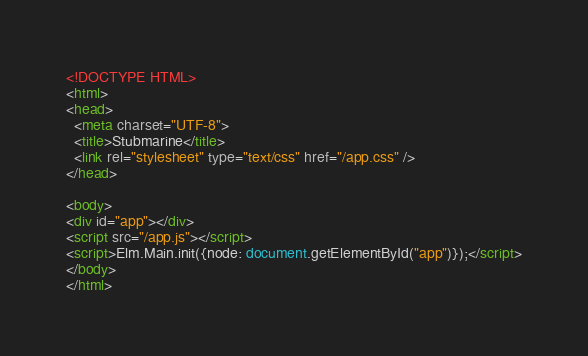<code> <loc_0><loc_0><loc_500><loc_500><_HTML_><!DOCTYPE HTML>
<html>
<head>
  <meta charset="UTF-8">
  <title>Stubmarine</title>
  <link rel="stylesheet" type="text/css" href="/app.css" />
</head>

<body>
<div id="app"></div>
<script src="/app.js"></script>
<script>Elm.Main.init({node: document.getElementById("app")});</script>
</body>
</html>
</code> 